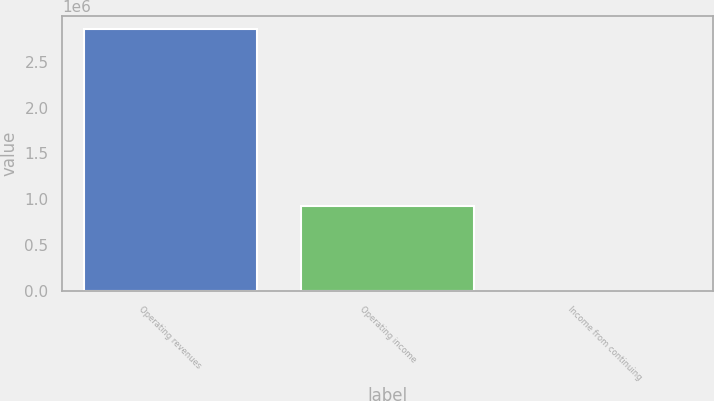<chart> <loc_0><loc_0><loc_500><loc_500><bar_chart><fcel>Operating revenues<fcel>Operating income<fcel>Income from continuing<nl><fcel>2.85393e+06<fcel>924104<fcel>2.1<nl></chart> 